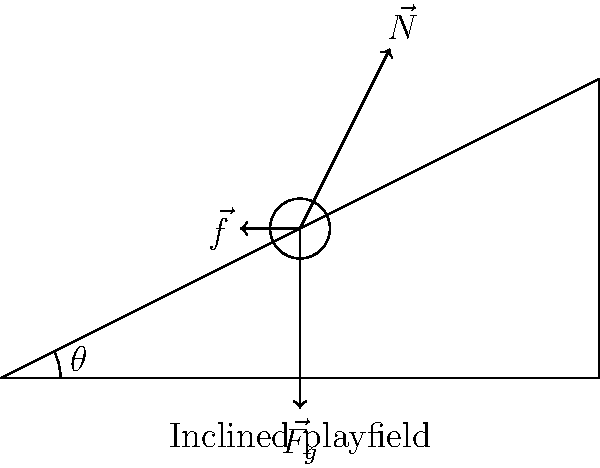As a pinball machine expert, you know that the angle of the playfield affects the ball's motion. In the diagram, identify the force that is parallel to the inclined playfield and responsible for the ball's acceleration down the slope. What is the relationship between this force, the angle of inclination ($\theta$), and the ball's weight ($mg$)? Let's break this down step-by-step:

1) The forces acting on the pinball are:
   - Weight ($\vec{F_g}$): Always vertically downward
   - Normal force ($\vec{N}$): Perpendicular to the surface
   - Friction force ($\vec{f}$): Parallel to the surface, opposing motion

2) The force parallel to the inclined playfield is the component of the weight that acts along the slope. This is the force responsible for the ball's acceleration down the slope.

3) To find this force, we need to resolve the weight vector into components parallel and perpendicular to the slope:
   - The component parallel to the slope: $F_\parallel = mg \sin(\theta)$
   - The component perpendicular to the slope: $F_\perp = mg \cos(\theta)$

4) The force causing the ball to accelerate down the slope is $F_\parallel = mg \sin(\theta)$

5) This shows that the force parallel to the slope (and thus responsible for the ball's acceleration) is directly proportional to:
   - The ball's weight ($mg$)
   - The sine of the inclination angle ($\sin(\theta)$)

Therefore, the relationship between the force causing acceleration, the angle of inclination, and the ball's weight is:

$F_\parallel = mg \sin(\theta)$

This relationship explains why steeper playfields (larger $\theta$) cause the ball to accelerate faster, a crucial aspect of pinball machine design and gameplay.
Answer: $F_\parallel = mg \sin(\theta)$ 